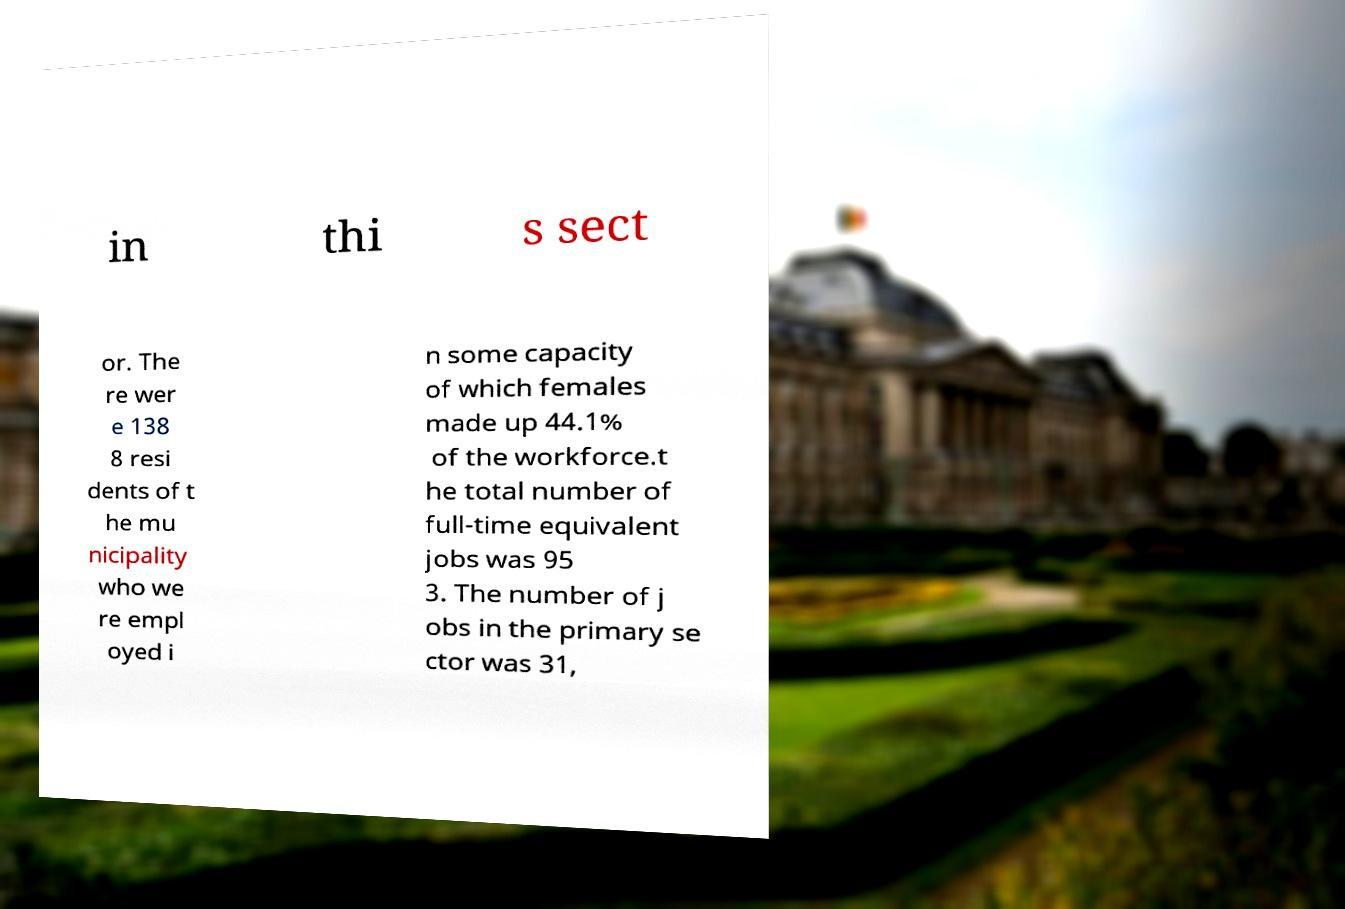There's text embedded in this image that I need extracted. Can you transcribe it verbatim? in thi s sect or. The re wer e 138 8 resi dents of t he mu nicipality who we re empl oyed i n some capacity of which females made up 44.1% of the workforce.t he total number of full-time equivalent jobs was 95 3. The number of j obs in the primary se ctor was 31, 